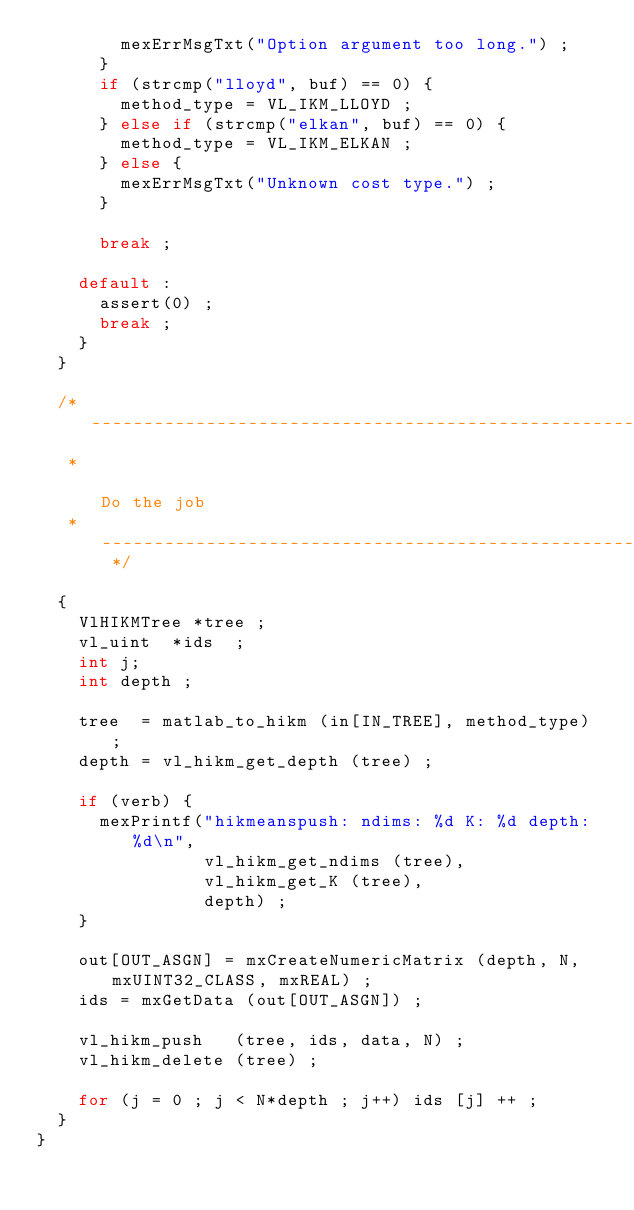<code> <loc_0><loc_0><loc_500><loc_500><_C_>        mexErrMsgTxt("Option argument too long.") ;
      }
      if (strcmp("lloyd", buf) == 0) {
        method_type = VL_IKM_LLOYD ;
      } else if (strcmp("elkan", buf) == 0) {
        method_type = VL_IKM_ELKAN ;
      } else {
        mexErrMsgTxt("Unknown cost type.") ;
      }
      
      break ;
      
    default :
      assert(0) ;
      break ;
    }
  }

  /* -----------------------------------------------------------------
   *                                                        Do the job
   * -------------------------------------------------------------- */

  {
    VlHIKMTree *tree ;
    vl_uint  *ids  ;
    int j;
    int depth ;

    tree  = matlab_to_hikm (in[IN_TREE], method_type) ;
    depth = vl_hikm_get_depth (tree) ;

    if (verb) {
      mexPrintf("hikmeanspush: ndims: %d K: %d depth: %d\n",
                vl_hikm_get_ndims (tree), 
                vl_hikm_get_K (tree),
                depth) ;
    }
    
    out[OUT_ASGN] = mxCreateNumericMatrix (depth, N, mxUINT32_CLASS, mxREAL) ;
    ids = mxGetData (out[OUT_ASGN]) ;

    vl_hikm_push   (tree, ids, data, N) ;    
    vl_hikm_delete (tree) ;
    
    for (j = 0 ; j < N*depth ; j++) ids [j] ++ ;
  }
}
</code> 